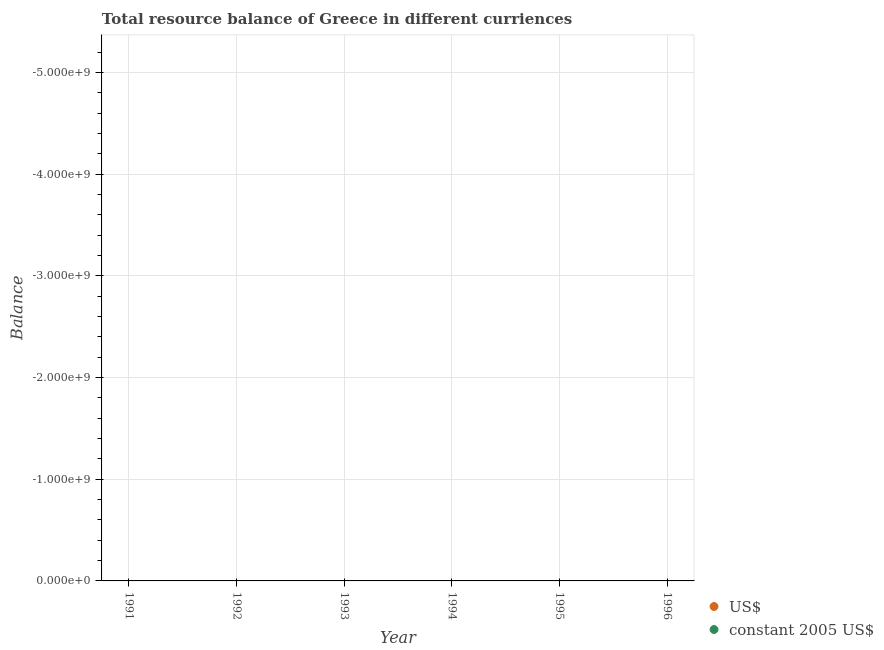What is the resource balance in us$ in 1992?
Your answer should be very brief. 0. Across all years, what is the minimum resource balance in us$?
Provide a succinct answer. 0. What is the total resource balance in constant us$ in the graph?
Keep it short and to the point. 0. Does the resource balance in us$ monotonically increase over the years?
Offer a very short reply. No. Is the resource balance in us$ strictly greater than the resource balance in constant us$ over the years?
Your answer should be compact. No. How many dotlines are there?
Provide a succinct answer. 0. How many years are there in the graph?
Your answer should be compact. 6. Does the graph contain any zero values?
Provide a short and direct response. Yes. Does the graph contain grids?
Your response must be concise. Yes. Where does the legend appear in the graph?
Give a very brief answer. Bottom right. How many legend labels are there?
Keep it short and to the point. 2. What is the title of the graph?
Make the answer very short. Total resource balance of Greece in different curriences. Does "Electricity" appear as one of the legend labels in the graph?
Your answer should be compact. No. What is the label or title of the Y-axis?
Ensure brevity in your answer.  Balance. What is the Balance of constant 2005 US$ in 1991?
Ensure brevity in your answer.  0. What is the Balance of US$ in 1993?
Give a very brief answer. 0. What is the Balance in constant 2005 US$ in 1993?
Your answer should be very brief. 0. What is the Balance of constant 2005 US$ in 1994?
Offer a terse response. 0. What is the Balance in US$ in 1995?
Offer a very short reply. 0. What is the Balance in US$ in 1996?
Offer a terse response. 0. What is the total Balance of US$ in the graph?
Keep it short and to the point. 0. 